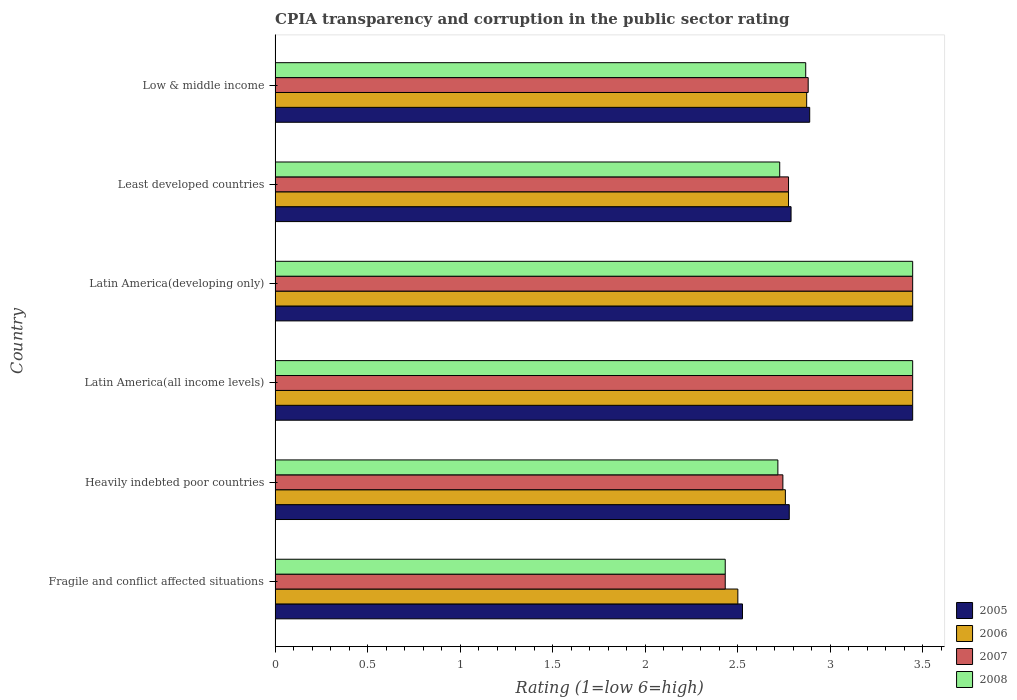How many different coloured bars are there?
Make the answer very short. 4. How many groups of bars are there?
Provide a short and direct response. 6. Are the number of bars per tick equal to the number of legend labels?
Provide a succinct answer. Yes. Are the number of bars on each tick of the Y-axis equal?
Keep it short and to the point. Yes. How many bars are there on the 4th tick from the top?
Keep it short and to the point. 4. How many bars are there on the 1st tick from the bottom?
Your answer should be very brief. 4. What is the label of the 6th group of bars from the top?
Offer a very short reply. Fragile and conflict affected situations. What is the CPIA rating in 2005 in Latin America(all income levels)?
Offer a very short reply. 3.44. Across all countries, what is the maximum CPIA rating in 2005?
Ensure brevity in your answer.  3.44. Across all countries, what is the minimum CPIA rating in 2005?
Make the answer very short. 2.52. In which country was the CPIA rating in 2005 maximum?
Make the answer very short. Latin America(all income levels). In which country was the CPIA rating in 2007 minimum?
Your answer should be very brief. Fragile and conflict affected situations. What is the total CPIA rating in 2006 in the graph?
Provide a short and direct response. 17.79. What is the difference between the CPIA rating in 2008 in Latin America(developing only) and that in Low & middle income?
Your answer should be very brief. 0.58. What is the difference between the CPIA rating in 2008 in Fragile and conflict affected situations and the CPIA rating in 2006 in Latin America(developing only)?
Provide a succinct answer. -1.01. What is the average CPIA rating in 2005 per country?
Ensure brevity in your answer.  2.98. What is the difference between the CPIA rating in 2007 and CPIA rating in 2008 in Least developed countries?
Keep it short and to the point. 0.05. In how many countries, is the CPIA rating in 2006 greater than 3.4 ?
Your answer should be very brief. 2. What is the ratio of the CPIA rating in 2006 in Latin America(all income levels) to that in Least developed countries?
Your response must be concise. 1.24. Is the difference between the CPIA rating in 2007 in Latin America(developing only) and Least developed countries greater than the difference between the CPIA rating in 2008 in Latin America(developing only) and Least developed countries?
Keep it short and to the point. No. What is the difference between the highest and the second highest CPIA rating in 2006?
Ensure brevity in your answer.  0. What is the difference between the highest and the lowest CPIA rating in 2006?
Keep it short and to the point. 0.94. Is it the case that in every country, the sum of the CPIA rating in 2006 and CPIA rating in 2007 is greater than the sum of CPIA rating in 2008 and CPIA rating in 2005?
Offer a terse response. No. What does the 3rd bar from the bottom in Low & middle income represents?
Keep it short and to the point. 2007. How many bars are there?
Offer a very short reply. 24. Are all the bars in the graph horizontal?
Your answer should be compact. Yes. What is the difference between two consecutive major ticks on the X-axis?
Keep it short and to the point. 0.5. Does the graph contain any zero values?
Give a very brief answer. No. Does the graph contain grids?
Give a very brief answer. No. Where does the legend appear in the graph?
Make the answer very short. Bottom right. How many legend labels are there?
Your response must be concise. 4. What is the title of the graph?
Your answer should be compact. CPIA transparency and corruption in the public sector rating. What is the label or title of the X-axis?
Offer a very short reply. Rating (1=low 6=high). What is the label or title of the Y-axis?
Keep it short and to the point. Country. What is the Rating (1=low 6=high) in 2005 in Fragile and conflict affected situations?
Give a very brief answer. 2.52. What is the Rating (1=low 6=high) in 2007 in Fragile and conflict affected situations?
Ensure brevity in your answer.  2.43. What is the Rating (1=low 6=high) of 2008 in Fragile and conflict affected situations?
Give a very brief answer. 2.43. What is the Rating (1=low 6=high) of 2005 in Heavily indebted poor countries?
Your response must be concise. 2.78. What is the Rating (1=low 6=high) of 2006 in Heavily indebted poor countries?
Your answer should be very brief. 2.76. What is the Rating (1=low 6=high) in 2007 in Heavily indebted poor countries?
Offer a very short reply. 2.74. What is the Rating (1=low 6=high) of 2008 in Heavily indebted poor countries?
Make the answer very short. 2.72. What is the Rating (1=low 6=high) in 2005 in Latin America(all income levels)?
Offer a terse response. 3.44. What is the Rating (1=low 6=high) in 2006 in Latin America(all income levels)?
Your answer should be compact. 3.44. What is the Rating (1=low 6=high) of 2007 in Latin America(all income levels)?
Make the answer very short. 3.44. What is the Rating (1=low 6=high) of 2008 in Latin America(all income levels)?
Your answer should be compact. 3.44. What is the Rating (1=low 6=high) in 2005 in Latin America(developing only)?
Offer a terse response. 3.44. What is the Rating (1=low 6=high) in 2006 in Latin America(developing only)?
Provide a succinct answer. 3.44. What is the Rating (1=low 6=high) of 2007 in Latin America(developing only)?
Make the answer very short. 3.44. What is the Rating (1=low 6=high) in 2008 in Latin America(developing only)?
Offer a terse response. 3.44. What is the Rating (1=low 6=high) of 2005 in Least developed countries?
Make the answer very short. 2.79. What is the Rating (1=low 6=high) of 2006 in Least developed countries?
Give a very brief answer. 2.77. What is the Rating (1=low 6=high) in 2007 in Least developed countries?
Offer a terse response. 2.77. What is the Rating (1=low 6=high) in 2008 in Least developed countries?
Provide a succinct answer. 2.73. What is the Rating (1=low 6=high) in 2005 in Low & middle income?
Offer a terse response. 2.89. What is the Rating (1=low 6=high) in 2006 in Low & middle income?
Your answer should be very brief. 2.87. What is the Rating (1=low 6=high) in 2007 in Low & middle income?
Ensure brevity in your answer.  2.88. What is the Rating (1=low 6=high) in 2008 in Low & middle income?
Keep it short and to the point. 2.87. Across all countries, what is the maximum Rating (1=low 6=high) in 2005?
Your answer should be compact. 3.44. Across all countries, what is the maximum Rating (1=low 6=high) of 2006?
Keep it short and to the point. 3.44. Across all countries, what is the maximum Rating (1=low 6=high) in 2007?
Your answer should be compact. 3.44. Across all countries, what is the maximum Rating (1=low 6=high) in 2008?
Give a very brief answer. 3.44. Across all countries, what is the minimum Rating (1=low 6=high) of 2005?
Offer a very short reply. 2.52. Across all countries, what is the minimum Rating (1=low 6=high) in 2007?
Offer a very short reply. 2.43. Across all countries, what is the minimum Rating (1=low 6=high) in 2008?
Provide a short and direct response. 2.43. What is the total Rating (1=low 6=high) in 2005 in the graph?
Ensure brevity in your answer.  17.87. What is the total Rating (1=low 6=high) of 2006 in the graph?
Your response must be concise. 17.79. What is the total Rating (1=low 6=high) of 2007 in the graph?
Ensure brevity in your answer.  17.72. What is the total Rating (1=low 6=high) in 2008 in the graph?
Ensure brevity in your answer.  17.63. What is the difference between the Rating (1=low 6=high) in 2005 in Fragile and conflict affected situations and that in Heavily indebted poor countries?
Offer a very short reply. -0.25. What is the difference between the Rating (1=low 6=high) in 2006 in Fragile and conflict affected situations and that in Heavily indebted poor countries?
Ensure brevity in your answer.  -0.26. What is the difference between the Rating (1=low 6=high) in 2007 in Fragile and conflict affected situations and that in Heavily indebted poor countries?
Provide a short and direct response. -0.31. What is the difference between the Rating (1=low 6=high) in 2008 in Fragile and conflict affected situations and that in Heavily indebted poor countries?
Ensure brevity in your answer.  -0.28. What is the difference between the Rating (1=low 6=high) in 2005 in Fragile and conflict affected situations and that in Latin America(all income levels)?
Keep it short and to the point. -0.92. What is the difference between the Rating (1=low 6=high) of 2006 in Fragile and conflict affected situations and that in Latin America(all income levels)?
Make the answer very short. -0.94. What is the difference between the Rating (1=low 6=high) of 2007 in Fragile and conflict affected situations and that in Latin America(all income levels)?
Make the answer very short. -1.01. What is the difference between the Rating (1=low 6=high) in 2008 in Fragile and conflict affected situations and that in Latin America(all income levels)?
Provide a succinct answer. -1.01. What is the difference between the Rating (1=low 6=high) in 2005 in Fragile and conflict affected situations and that in Latin America(developing only)?
Provide a short and direct response. -0.92. What is the difference between the Rating (1=low 6=high) in 2006 in Fragile and conflict affected situations and that in Latin America(developing only)?
Give a very brief answer. -0.94. What is the difference between the Rating (1=low 6=high) in 2007 in Fragile and conflict affected situations and that in Latin America(developing only)?
Give a very brief answer. -1.01. What is the difference between the Rating (1=low 6=high) of 2008 in Fragile and conflict affected situations and that in Latin America(developing only)?
Offer a terse response. -1.01. What is the difference between the Rating (1=low 6=high) of 2005 in Fragile and conflict affected situations and that in Least developed countries?
Provide a short and direct response. -0.26. What is the difference between the Rating (1=low 6=high) in 2006 in Fragile and conflict affected situations and that in Least developed countries?
Your answer should be very brief. -0.27. What is the difference between the Rating (1=low 6=high) of 2007 in Fragile and conflict affected situations and that in Least developed countries?
Keep it short and to the point. -0.34. What is the difference between the Rating (1=low 6=high) in 2008 in Fragile and conflict affected situations and that in Least developed countries?
Your answer should be compact. -0.29. What is the difference between the Rating (1=low 6=high) of 2005 in Fragile and conflict affected situations and that in Low & middle income?
Make the answer very short. -0.36. What is the difference between the Rating (1=low 6=high) in 2006 in Fragile and conflict affected situations and that in Low & middle income?
Give a very brief answer. -0.37. What is the difference between the Rating (1=low 6=high) of 2007 in Fragile and conflict affected situations and that in Low & middle income?
Keep it short and to the point. -0.45. What is the difference between the Rating (1=low 6=high) in 2008 in Fragile and conflict affected situations and that in Low & middle income?
Offer a terse response. -0.43. What is the difference between the Rating (1=low 6=high) in 2006 in Heavily indebted poor countries and that in Latin America(all income levels)?
Your response must be concise. -0.69. What is the difference between the Rating (1=low 6=high) in 2007 in Heavily indebted poor countries and that in Latin America(all income levels)?
Make the answer very short. -0.7. What is the difference between the Rating (1=low 6=high) of 2008 in Heavily indebted poor countries and that in Latin America(all income levels)?
Make the answer very short. -0.73. What is the difference between the Rating (1=low 6=high) in 2005 in Heavily indebted poor countries and that in Latin America(developing only)?
Offer a very short reply. -0.67. What is the difference between the Rating (1=low 6=high) in 2006 in Heavily indebted poor countries and that in Latin America(developing only)?
Make the answer very short. -0.69. What is the difference between the Rating (1=low 6=high) in 2007 in Heavily indebted poor countries and that in Latin America(developing only)?
Your answer should be very brief. -0.7. What is the difference between the Rating (1=low 6=high) in 2008 in Heavily indebted poor countries and that in Latin America(developing only)?
Your response must be concise. -0.73. What is the difference between the Rating (1=low 6=high) in 2005 in Heavily indebted poor countries and that in Least developed countries?
Provide a short and direct response. -0.01. What is the difference between the Rating (1=low 6=high) in 2006 in Heavily indebted poor countries and that in Least developed countries?
Keep it short and to the point. -0.02. What is the difference between the Rating (1=low 6=high) in 2007 in Heavily indebted poor countries and that in Least developed countries?
Ensure brevity in your answer.  -0.03. What is the difference between the Rating (1=low 6=high) in 2008 in Heavily indebted poor countries and that in Least developed countries?
Give a very brief answer. -0.01. What is the difference between the Rating (1=low 6=high) of 2005 in Heavily indebted poor countries and that in Low & middle income?
Keep it short and to the point. -0.11. What is the difference between the Rating (1=low 6=high) of 2006 in Heavily indebted poor countries and that in Low & middle income?
Your answer should be compact. -0.12. What is the difference between the Rating (1=low 6=high) of 2007 in Heavily indebted poor countries and that in Low & middle income?
Give a very brief answer. -0.14. What is the difference between the Rating (1=low 6=high) in 2008 in Heavily indebted poor countries and that in Low & middle income?
Provide a succinct answer. -0.15. What is the difference between the Rating (1=low 6=high) of 2005 in Latin America(all income levels) and that in Least developed countries?
Provide a succinct answer. 0.66. What is the difference between the Rating (1=low 6=high) in 2006 in Latin America(all income levels) and that in Least developed countries?
Give a very brief answer. 0.67. What is the difference between the Rating (1=low 6=high) in 2007 in Latin America(all income levels) and that in Least developed countries?
Your answer should be compact. 0.67. What is the difference between the Rating (1=low 6=high) in 2008 in Latin America(all income levels) and that in Least developed countries?
Provide a short and direct response. 0.72. What is the difference between the Rating (1=low 6=high) of 2005 in Latin America(all income levels) and that in Low & middle income?
Your response must be concise. 0.56. What is the difference between the Rating (1=low 6=high) in 2006 in Latin America(all income levels) and that in Low & middle income?
Your answer should be very brief. 0.57. What is the difference between the Rating (1=low 6=high) of 2007 in Latin America(all income levels) and that in Low & middle income?
Give a very brief answer. 0.56. What is the difference between the Rating (1=low 6=high) of 2008 in Latin America(all income levels) and that in Low & middle income?
Your answer should be compact. 0.58. What is the difference between the Rating (1=low 6=high) in 2005 in Latin America(developing only) and that in Least developed countries?
Your answer should be compact. 0.66. What is the difference between the Rating (1=low 6=high) in 2006 in Latin America(developing only) and that in Least developed countries?
Provide a short and direct response. 0.67. What is the difference between the Rating (1=low 6=high) of 2007 in Latin America(developing only) and that in Least developed countries?
Make the answer very short. 0.67. What is the difference between the Rating (1=low 6=high) of 2008 in Latin America(developing only) and that in Least developed countries?
Provide a short and direct response. 0.72. What is the difference between the Rating (1=low 6=high) of 2005 in Latin America(developing only) and that in Low & middle income?
Ensure brevity in your answer.  0.56. What is the difference between the Rating (1=low 6=high) of 2006 in Latin America(developing only) and that in Low & middle income?
Keep it short and to the point. 0.57. What is the difference between the Rating (1=low 6=high) of 2007 in Latin America(developing only) and that in Low & middle income?
Your response must be concise. 0.56. What is the difference between the Rating (1=low 6=high) in 2008 in Latin America(developing only) and that in Low & middle income?
Your response must be concise. 0.58. What is the difference between the Rating (1=low 6=high) in 2005 in Least developed countries and that in Low & middle income?
Keep it short and to the point. -0.1. What is the difference between the Rating (1=low 6=high) in 2006 in Least developed countries and that in Low & middle income?
Give a very brief answer. -0.1. What is the difference between the Rating (1=low 6=high) in 2007 in Least developed countries and that in Low & middle income?
Your answer should be very brief. -0.11. What is the difference between the Rating (1=low 6=high) of 2008 in Least developed countries and that in Low & middle income?
Your response must be concise. -0.14. What is the difference between the Rating (1=low 6=high) of 2005 in Fragile and conflict affected situations and the Rating (1=low 6=high) of 2006 in Heavily indebted poor countries?
Your answer should be compact. -0.23. What is the difference between the Rating (1=low 6=high) of 2005 in Fragile and conflict affected situations and the Rating (1=low 6=high) of 2007 in Heavily indebted poor countries?
Give a very brief answer. -0.22. What is the difference between the Rating (1=low 6=high) in 2005 in Fragile and conflict affected situations and the Rating (1=low 6=high) in 2008 in Heavily indebted poor countries?
Give a very brief answer. -0.19. What is the difference between the Rating (1=low 6=high) in 2006 in Fragile and conflict affected situations and the Rating (1=low 6=high) in 2007 in Heavily indebted poor countries?
Your answer should be compact. -0.24. What is the difference between the Rating (1=low 6=high) of 2006 in Fragile and conflict affected situations and the Rating (1=low 6=high) of 2008 in Heavily indebted poor countries?
Keep it short and to the point. -0.22. What is the difference between the Rating (1=low 6=high) in 2007 in Fragile and conflict affected situations and the Rating (1=low 6=high) in 2008 in Heavily indebted poor countries?
Your response must be concise. -0.28. What is the difference between the Rating (1=low 6=high) in 2005 in Fragile and conflict affected situations and the Rating (1=low 6=high) in 2006 in Latin America(all income levels)?
Give a very brief answer. -0.92. What is the difference between the Rating (1=low 6=high) in 2005 in Fragile and conflict affected situations and the Rating (1=low 6=high) in 2007 in Latin America(all income levels)?
Provide a short and direct response. -0.92. What is the difference between the Rating (1=low 6=high) of 2005 in Fragile and conflict affected situations and the Rating (1=low 6=high) of 2008 in Latin America(all income levels)?
Give a very brief answer. -0.92. What is the difference between the Rating (1=low 6=high) in 2006 in Fragile and conflict affected situations and the Rating (1=low 6=high) in 2007 in Latin America(all income levels)?
Offer a very short reply. -0.94. What is the difference between the Rating (1=low 6=high) of 2006 in Fragile and conflict affected situations and the Rating (1=low 6=high) of 2008 in Latin America(all income levels)?
Provide a short and direct response. -0.94. What is the difference between the Rating (1=low 6=high) in 2007 in Fragile and conflict affected situations and the Rating (1=low 6=high) in 2008 in Latin America(all income levels)?
Offer a terse response. -1.01. What is the difference between the Rating (1=low 6=high) of 2005 in Fragile and conflict affected situations and the Rating (1=low 6=high) of 2006 in Latin America(developing only)?
Make the answer very short. -0.92. What is the difference between the Rating (1=low 6=high) in 2005 in Fragile and conflict affected situations and the Rating (1=low 6=high) in 2007 in Latin America(developing only)?
Offer a very short reply. -0.92. What is the difference between the Rating (1=low 6=high) of 2005 in Fragile and conflict affected situations and the Rating (1=low 6=high) of 2008 in Latin America(developing only)?
Your answer should be compact. -0.92. What is the difference between the Rating (1=low 6=high) in 2006 in Fragile and conflict affected situations and the Rating (1=low 6=high) in 2007 in Latin America(developing only)?
Keep it short and to the point. -0.94. What is the difference between the Rating (1=low 6=high) of 2006 in Fragile and conflict affected situations and the Rating (1=low 6=high) of 2008 in Latin America(developing only)?
Give a very brief answer. -0.94. What is the difference between the Rating (1=low 6=high) of 2007 in Fragile and conflict affected situations and the Rating (1=low 6=high) of 2008 in Latin America(developing only)?
Offer a very short reply. -1.01. What is the difference between the Rating (1=low 6=high) of 2005 in Fragile and conflict affected situations and the Rating (1=low 6=high) of 2006 in Least developed countries?
Ensure brevity in your answer.  -0.25. What is the difference between the Rating (1=low 6=high) in 2005 in Fragile and conflict affected situations and the Rating (1=low 6=high) in 2007 in Least developed countries?
Your answer should be very brief. -0.25. What is the difference between the Rating (1=low 6=high) in 2005 in Fragile and conflict affected situations and the Rating (1=low 6=high) in 2008 in Least developed countries?
Give a very brief answer. -0.2. What is the difference between the Rating (1=low 6=high) in 2006 in Fragile and conflict affected situations and the Rating (1=low 6=high) in 2007 in Least developed countries?
Provide a succinct answer. -0.27. What is the difference between the Rating (1=low 6=high) in 2006 in Fragile and conflict affected situations and the Rating (1=low 6=high) in 2008 in Least developed countries?
Ensure brevity in your answer.  -0.23. What is the difference between the Rating (1=low 6=high) in 2007 in Fragile and conflict affected situations and the Rating (1=low 6=high) in 2008 in Least developed countries?
Provide a short and direct response. -0.29. What is the difference between the Rating (1=low 6=high) of 2005 in Fragile and conflict affected situations and the Rating (1=low 6=high) of 2006 in Low & middle income?
Provide a succinct answer. -0.35. What is the difference between the Rating (1=low 6=high) in 2005 in Fragile and conflict affected situations and the Rating (1=low 6=high) in 2007 in Low & middle income?
Your answer should be compact. -0.35. What is the difference between the Rating (1=low 6=high) of 2005 in Fragile and conflict affected situations and the Rating (1=low 6=high) of 2008 in Low & middle income?
Keep it short and to the point. -0.34. What is the difference between the Rating (1=low 6=high) in 2006 in Fragile and conflict affected situations and the Rating (1=low 6=high) in 2007 in Low & middle income?
Offer a very short reply. -0.38. What is the difference between the Rating (1=low 6=high) of 2006 in Fragile and conflict affected situations and the Rating (1=low 6=high) of 2008 in Low & middle income?
Keep it short and to the point. -0.37. What is the difference between the Rating (1=low 6=high) of 2007 in Fragile and conflict affected situations and the Rating (1=low 6=high) of 2008 in Low & middle income?
Offer a very short reply. -0.43. What is the difference between the Rating (1=low 6=high) in 2005 in Heavily indebted poor countries and the Rating (1=low 6=high) in 2006 in Latin America(all income levels)?
Keep it short and to the point. -0.67. What is the difference between the Rating (1=low 6=high) in 2006 in Heavily indebted poor countries and the Rating (1=low 6=high) in 2007 in Latin America(all income levels)?
Your answer should be compact. -0.69. What is the difference between the Rating (1=low 6=high) in 2006 in Heavily indebted poor countries and the Rating (1=low 6=high) in 2008 in Latin America(all income levels)?
Ensure brevity in your answer.  -0.69. What is the difference between the Rating (1=low 6=high) of 2007 in Heavily indebted poor countries and the Rating (1=low 6=high) of 2008 in Latin America(all income levels)?
Keep it short and to the point. -0.7. What is the difference between the Rating (1=low 6=high) in 2005 in Heavily indebted poor countries and the Rating (1=low 6=high) in 2007 in Latin America(developing only)?
Provide a short and direct response. -0.67. What is the difference between the Rating (1=low 6=high) of 2005 in Heavily indebted poor countries and the Rating (1=low 6=high) of 2008 in Latin America(developing only)?
Your response must be concise. -0.67. What is the difference between the Rating (1=low 6=high) of 2006 in Heavily indebted poor countries and the Rating (1=low 6=high) of 2007 in Latin America(developing only)?
Offer a very short reply. -0.69. What is the difference between the Rating (1=low 6=high) of 2006 in Heavily indebted poor countries and the Rating (1=low 6=high) of 2008 in Latin America(developing only)?
Keep it short and to the point. -0.69. What is the difference between the Rating (1=low 6=high) in 2007 in Heavily indebted poor countries and the Rating (1=low 6=high) in 2008 in Latin America(developing only)?
Your answer should be compact. -0.7. What is the difference between the Rating (1=low 6=high) of 2005 in Heavily indebted poor countries and the Rating (1=low 6=high) of 2006 in Least developed countries?
Make the answer very short. 0. What is the difference between the Rating (1=low 6=high) in 2005 in Heavily indebted poor countries and the Rating (1=low 6=high) in 2007 in Least developed countries?
Offer a very short reply. 0. What is the difference between the Rating (1=low 6=high) of 2005 in Heavily indebted poor countries and the Rating (1=low 6=high) of 2008 in Least developed countries?
Your answer should be very brief. 0.05. What is the difference between the Rating (1=low 6=high) in 2006 in Heavily indebted poor countries and the Rating (1=low 6=high) in 2007 in Least developed countries?
Your answer should be very brief. -0.02. What is the difference between the Rating (1=low 6=high) of 2006 in Heavily indebted poor countries and the Rating (1=low 6=high) of 2008 in Least developed countries?
Give a very brief answer. 0.03. What is the difference between the Rating (1=low 6=high) of 2007 in Heavily indebted poor countries and the Rating (1=low 6=high) of 2008 in Least developed countries?
Your answer should be compact. 0.02. What is the difference between the Rating (1=low 6=high) in 2005 in Heavily indebted poor countries and the Rating (1=low 6=high) in 2006 in Low & middle income?
Your answer should be very brief. -0.09. What is the difference between the Rating (1=low 6=high) of 2005 in Heavily indebted poor countries and the Rating (1=low 6=high) of 2007 in Low & middle income?
Give a very brief answer. -0.1. What is the difference between the Rating (1=low 6=high) in 2005 in Heavily indebted poor countries and the Rating (1=low 6=high) in 2008 in Low & middle income?
Offer a terse response. -0.09. What is the difference between the Rating (1=low 6=high) in 2006 in Heavily indebted poor countries and the Rating (1=low 6=high) in 2007 in Low & middle income?
Make the answer very short. -0.12. What is the difference between the Rating (1=low 6=high) in 2006 in Heavily indebted poor countries and the Rating (1=low 6=high) in 2008 in Low & middle income?
Your answer should be compact. -0.11. What is the difference between the Rating (1=low 6=high) in 2007 in Heavily indebted poor countries and the Rating (1=low 6=high) in 2008 in Low & middle income?
Offer a terse response. -0.12. What is the difference between the Rating (1=low 6=high) of 2005 in Latin America(all income levels) and the Rating (1=low 6=high) of 2007 in Latin America(developing only)?
Offer a terse response. 0. What is the difference between the Rating (1=low 6=high) of 2005 in Latin America(all income levels) and the Rating (1=low 6=high) of 2008 in Latin America(developing only)?
Your response must be concise. 0. What is the difference between the Rating (1=low 6=high) of 2006 in Latin America(all income levels) and the Rating (1=low 6=high) of 2008 in Latin America(developing only)?
Give a very brief answer. 0. What is the difference between the Rating (1=low 6=high) of 2007 in Latin America(all income levels) and the Rating (1=low 6=high) of 2008 in Latin America(developing only)?
Provide a short and direct response. 0. What is the difference between the Rating (1=low 6=high) of 2005 in Latin America(all income levels) and the Rating (1=low 6=high) of 2006 in Least developed countries?
Make the answer very short. 0.67. What is the difference between the Rating (1=low 6=high) of 2005 in Latin America(all income levels) and the Rating (1=low 6=high) of 2007 in Least developed countries?
Your answer should be compact. 0.67. What is the difference between the Rating (1=low 6=high) of 2005 in Latin America(all income levels) and the Rating (1=low 6=high) of 2008 in Least developed countries?
Your answer should be very brief. 0.72. What is the difference between the Rating (1=low 6=high) of 2006 in Latin America(all income levels) and the Rating (1=low 6=high) of 2007 in Least developed countries?
Offer a terse response. 0.67. What is the difference between the Rating (1=low 6=high) of 2006 in Latin America(all income levels) and the Rating (1=low 6=high) of 2008 in Least developed countries?
Provide a succinct answer. 0.72. What is the difference between the Rating (1=low 6=high) of 2007 in Latin America(all income levels) and the Rating (1=low 6=high) of 2008 in Least developed countries?
Offer a very short reply. 0.72. What is the difference between the Rating (1=low 6=high) in 2005 in Latin America(all income levels) and the Rating (1=low 6=high) in 2006 in Low & middle income?
Keep it short and to the point. 0.57. What is the difference between the Rating (1=low 6=high) of 2005 in Latin America(all income levels) and the Rating (1=low 6=high) of 2007 in Low & middle income?
Make the answer very short. 0.56. What is the difference between the Rating (1=low 6=high) of 2005 in Latin America(all income levels) and the Rating (1=low 6=high) of 2008 in Low & middle income?
Provide a succinct answer. 0.58. What is the difference between the Rating (1=low 6=high) in 2006 in Latin America(all income levels) and the Rating (1=low 6=high) in 2007 in Low & middle income?
Offer a terse response. 0.56. What is the difference between the Rating (1=low 6=high) of 2006 in Latin America(all income levels) and the Rating (1=low 6=high) of 2008 in Low & middle income?
Keep it short and to the point. 0.58. What is the difference between the Rating (1=low 6=high) of 2007 in Latin America(all income levels) and the Rating (1=low 6=high) of 2008 in Low & middle income?
Your answer should be very brief. 0.58. What is the difference between the Rating (1=low 6=high) in 2005 in Latin America(developing only) and the Rating (1=low 6=high) in 2006 in Least developed countries?
Provide a short and direct response. 0.67. What is the difference between the Rating (1=low 6=high) in 2005 in Latin America(developing only) and the Rating (1=low 6=high) in 2007 in Least developed countries?
Your answer should be compact. 0.67. What is the difference between the Rating (1=low 6=high) of 2005 in Latin America(developing only) and the Rating (1=low 6=high) of 2008 in Least developed countries?
Provide a succinct answer. 0.72. What is the difference between the Rating (1=low 6=high) of 2006 in Latin America(developing only) and the Rating (1=low 6=high) of 2007 in Least developed countries?
Your response must be concise. 0.67. What is the difference between the Rating (1=low 6=high) in 2006 in Latin America(developing only) and the Rating (1=low 6=high) in 2008 in Least developed countries?
Your response must be concise. 0.72. What is the difference between the Rating (1=low 6=high) of 2007 in Latin America(developing only) and the Rating (1=low 6=high) of 2008 in Least developed countries?
Provide a short and direct response. 0.72. What is the difference between the Rating (1=low 6=high) of 2005 in Latin America(developing only) and the Rating (1=low 6=high) of 2006 in Low & middle income?
Provide a succinct answer. 0.57. What is the difference between the Rating (1=low 6=high) in 2005 in Latin America(developing only) and the Rating (1=low 6=high) in 2007 in Low & middle income?
Offer a very short reply. 0.56. What is the difference between the Rating (1=low 6=high) in 2005 in Latin America(developing only) and the Rating (1=low 6=high) in 2008 in Low & middle income?
Provide a succinct answer. 0.58. What is the difference between the Rating (1=low 6=high) of 2006 in Latin America(developing only) and the Rating (1=low 6=high) of 2007 in Low & middle income?
Your response must be concise. 0.56. What is the difference between the Rating (1=low 6=high) of 2006 in Latin America(developing only) and the Rating (1=low 6=high) of 2008 in Low & middle income?
Give a very brief answer. 0.58. What is the difference between the Rating (1=low 6=high) in 2007 in Latin America(developing only) and the Rating (1=low 6=high) in 2008 in Low & middle income?
Your answer should be compact. 0.58. What is the difference between the Rating (1=low 6=high) of 2005 in Least developed countries and the Rating (1=low 6=high) of 2006 in Low & middle income?
Provide a short and direct response. -0.08. What is the difference between the Rating (1=low 6=high) of 2005 in Least developed countries and the Rating (1=low 6=high) of 2007 in Low & middle income?
Give a very brief answer. -0.09. What is the difference between the Rating (1=low 6=high) of 2005 in Least developed countries and the Rating (1=low 6=high) of 2008 in Low & middle income?
Make the answer very short. -0.08. What is the difference between the Rating (1=low 6=high) in 2006 in Least developed countries and the Rating (1=low 6=high) in 2007 in Low & middle income?
Give a very brief answer. -0.11. What is the difference between the Rating (1=low 6=high) of 2006 in Least developed countries and the Rating (1=low 6=high) of 2008 in Low & middle income?
Your response must be concise. -0.09. What is the difference between the Rating (1=low 6=high) in 2007 in Least developed countries and the Rating (1=low 6=high) in 2008 in Low & middle income?
Provide a succinct answer. -0.09. What is the average Rating (1=low 6=high) of 2005 per country?
Make the answer very short. 2.98. What is the average Rating (1=low 6=high) of 2006 per country?
Give a very brief answer. 2.97. What is the average Rating (1=low 6=high) of 2007 per country?
Your answer should be very brief. 2.95. What is the average Rating (1=low 6=high) in 2008 per country?
Your response must be concise. 2.94. What is the difference between the Rating (1=low 6=high) of 2005 and Rating (1=low 6=high) of 2006 in Fragile and conflict affected situations?
Your answer should be very brief. 0.03. What is the difference between the Rating (1=low 6=high) of 2005 and Rating (1=low 6=high) of 2007 in Fragile and conflict affected situations?
Give a very brief answer. 0.09. What is the difference between the Rating (1=low 6=high) in 2005 and Rating (1=low 6=high) in 2008 in Fragile and conflict affected situations?
Ensure brevity in your answer.  0.09. What is the difference between the Rating (1=low 6=high) in 2006 and Rating (1=low 6=high) in 2007 in Fragile and conflict affected situations?
Make the answer very short. 0.07. What is the difference between the Rating (1=low 6=high) of 2006 and Rating (1=low 6=high) of 2008 in Fragile and conflict affected situations?
Offer a very short reply. 0.07. What is the difference between the Rating (1=low 6=high) of 2005 and Rating (1=low 6=high) of 2006 in Heavily indebted poor countries?
Your answer should be very brief. 0.02. What is the difference between the Rating (1=low 6=high) in 2005 and Rating (1=low 6=high) in 2007 in Heavily indebted poor countries?
Keep it short and to the point. 0.03. What is the difference between the Rating (1=low 6=high) in 2005 and Rating (1=low 6=high) in 2008 in Heavily indebted poor countries?
Keep it short and to the point. 0.06. What is the difference between the Rating (1=low 6=high) in 2006 and Rating (1=low 6=high) in 2007 in Heavily indebted poor countries?
Ensure brevity in your answer.  0.01. What is the difference between the Rating (1=low 6=high) in 2006 and Rating (1=low 6=high) in 2008 in Heavily indebted poor countries?
Provide a succinct answer. 0.04. What is the difference between the Rating (1=low 6=high) of 2007 and Rating (1=low 6=high) of 2008 in Heavily indebted poor countries?
Make the answer very short. 0.03. What is the difference between the Rating (1=low 6=high) in 2005 and Rating (1=low 6=high) in 2006 in Latin America(all income levels)?
Offer a terse response. 0. What is the difference between the Rating (1=low 6=high) of 2006 and Rating (1=low 6=high) of 2007 in Latin America(all income levels)?
Provide a succinct answer. 0. What is the difference between the Rating (1=low 6=high) in 2006 and Rating (1=low 6=high) in 2008 in Latin America(all income levels)?
Offer a very short reply. 0. What is the difference between the Rating (1=low 6=high) of 2005 and Rating (1=low 6=high) of 2006 in Latin America(developing only)?
Ensure brevity in your answer.  0. What is the difference between the Rating (1=low 6=high) in 2005 and Rating (1=low 6=high) in 2007 in Latin America(developing only)?
Your response must be concise. 0. What is the difference between the Rating (1=low 6=high) in 2005 and Rating (1=low 6=high) in 2008 in Latin America(developing only)?
Your answer should be very brief. 0. What is the difference between the Rating (1=low 6=high) of 2005 and Rating (1=low 6=high) of 2006 in Least developed countries?
Your answer should be compact. 0.01. What is the difference between the Rating (1=low 6=high) in 2005 and Rating (1=low 6=high) in 2007 in Least developed countries?
Ensure brevity in your answer.  0.01. What is the difference between the Rating (1=low 6=high) in 2005 and Rating (1=low 6=high) in 2008 in Least developed countries?
Give a very brief answer. 0.06. What is the difference between the Rating (1=low 6=high) of 2006 and Rating (1=low 6=high) of 2008 in Least developed countries?
Ensure brevity in your answer.  0.05. What is the difference between the Rating (1=low 6=high) in 2007 and Rating (1=low 6=high) in 2008 in Least developed countries?
Your response must be concise. 0.05. What is the difference between the Rating (1=low 6=high) of 2005 and Rating (1=low 6=high) of 2006 in Low & middle income?
Your response must be concise. 0.02. What is the difference between the Rating (1=low 6=high) of 2005 and Rating (1=low 6=high) of 2007 in Low & middle income?
Offer a very short reply. 0.01. What is the difference between the Rating (1=low 6=high) in 2005 and Rating (1=low 6=high) in 2008 in Low & middle income?
Your response must be concise. 0.02. What is the difference between the Rating (1=low 6=high) in 2006 and Rating (1=low 6=high) in 2007 in Low & middle income?
Offer a terse response. -0.01. What is the difference between the Rating (1=low 6=high) in 2006 and Rating (1=low 6=high) in 2008 in Low & middle income?
Your response must be concise. 0.01. What is the difference between the Rating (1=low 6=high) of 2007 and Rating (1=low 6=high) of 2008 in Low & middle income?
Offer a terse response. 0.01. What is the ratio of the Rating (1=low 6=high) of 2005 in Fragile and conflict affected situations to that in Heavily indebted poor countries?
Provide a succinct answer. 0.91. What is the ratio of the Rating (1=low 6=high) of 2006 in Fragile and conflict affected situations to that in Heavily indebted poor countries?
Your response must be concise. 0.91. What is the ratio of the Rating (1=low 6=high) in 2007 in Fragile and conflict affected situations to that in Heavily indebted poor countries?
Give a very brief answer. 0.89. What is the ratio of the Rating (1=low 6=high) of 2008 in Fragile and conflict affected situations to that in Heavily indebted poor countries?
Provide a succinct answer. 0.9. What is the ratio of the Rating (1=low 6=high) in 2005 in Fragile and conflict affected situations to that in Latin America(all income levels)?
Offer a terse response. 0.73. What is the ratio of the Rating (1=low 6=high) in 2006 in Fragile and conflict affected situations to that in Latin America(all income levels)?
Provide a succinct answer. 0.73. What is the ratio of the Rating (1=low 6=high) in 2007 in Fragile and conflict affected situations to that in Latin America(all income levels)?
Offer a terse response. 0.71. What is the ratio of the Rating (1=low 6=high) in 2008 in Fragile and conflict affected situations to that in Latin America(all income levels)?
Ensure brevity in your answer.  0.71. What is the ratio of the Rating (1=low 6=high) of 2005 in Fragile and conflict affected situations to that in Latin America(developing only)?
Ensure brevity in your answer.  0.73. What is the ratio of the Rating (1=low 6=high) of 2006 in Fragile and conflict affected situations to that in Latin America(developing only)?
Offer a very short reply. 0.73. What is the ratio of the Rating (1=low 6=high) in 2007 in Fragile and conflict affected situations to that in Latin America(developing only)?
Keep it short and to the point. 0.71. What is the ratio of the Rating (1=low 6=high) of 2008 in Fragile and conflict affected situations to that in Latin America(developing only)?
Your answer should be compact. 0.71. What is the ratio of the Rating (1=low 6=high) in 2005 in Fragile and conflict affected situations to that in Least developed countries?
Offer a very short reply. 0.91. What is the ratio of the Rating (1=low 6=high) in 2006 in Fragile and conflict affected situations to that in Least developed countries?
Offer a terse response. 0.9. What is the ratio of the Rating (1=low 6=high) in 2007 in Fragile and conflict affected situations to that in Least developed countries?
Your answer should be very brief. 0.88. What is the ratio of the Rating (1=low 6=high) of 2008 in Fragile and conflict affected situations to that in Least developed countries?
Offer a terse response. 0.89. What is the ratio of the Rating (1=low 6=high) of 2005 in Fragile and conflict affected situations to that in Low & middle income?
Offer a terse response. 0.87. What is the ratio of the Rating (1=low 6=high) in 2006 in Fragile and conflict affected situations to that in Low & middle income?
Offer a terse response. 0.87. What is the ratio of the Rating (1=low 6=high) of 2007 in Fragile and conflict affected situations to that in Low & middle income?
Ensure brevity in your answer.  0.84. What is the ratio of the Rating (1=low 6=high) in 2008 in Fragile and conflict affected situations to that in Low & middle income?
Offer a very short reply. 0.85. What is the ratio of the Rating (1=low 6=high) in 2005 in Heavily indebted poor countries to that in Latin America(all income levels)?
Offer a terse response. 0.81. What is the ratio of the Rating (1=low 6=high) of 2006 in Heavily indebted poor countries to that in Latin America(all income levels)?
Your answer should be compact. 0.8. What is the ratio of the Rating (1=low 6=high) of 2007 in Heavily indebted poor countries to that in Latin America(all income levels)?
Ensure brevity in your answer.  0.8. What is the ratio of the Rating (1=low 6=high) in 2008 in Heavily indebted poor countries to that in Latin America(all income levels)?
Your response must be concise. 0.79. What is the ratio of the Rating (1=low 6=high) in 2005 in Heavily indebted poor countries to that in Latin America(developing only)?
Provide a short and direct response. 0.81. What is the ratio of the Rating (1=low 6=high) of 2006 in Heavily indebted poor countries to that in Latin America(developing only)?
Make the answer very short. 0.8. What is the ratio of the Rating (1=low 6=high) of 2007 in Heavily indebted poor countries to that in Latin America(developing only)?
Offer a terse response. 0.8. What is the ratio of the Rating (1=low 6=high) in 2008 in Heavily indebted poor countries to that in Latin America(developing only)?
Keep it short and to the point. 0.79. What is the ratio of the Rating (1=low 6=high) of 2007 in Heavily indebted poor countries to that in Least developed countries?
Ensure brevity in your answer.  0.99. What is the ratio of the Rating (1=low 6=high) of 2005 in Heavily indebted poor countries to that in Low & middle income?
Your answer should be very brief. 0.96. What is the ratio of the Rating (1=low 6=high) in 2006 in Heavily indebted poor countries to that in Low & middle income?
Make the answer very short. 0.96. What is the ratio of the Rating (1=low 6=high) of 2007 in Heavily indebted poor countries to that in Low & middle income?
Give a very brief answer. 0.95. What is the ratio of the Rating (1=low 6=high) in 2008 in Heavily indebted poor countries to that in Low & middle income?
Give a very brief answer. 0.95. What is the ratio of the Rating (1=low 6=high) of 2006 in Latin America(all income levels) to that in Latin America(developing only)?
Ensure brevity in your answer.  1. What is the ratio of the Rating (1=low 6=high) of 2005 in Latin America(all income levels) to that in Least developed countries?
Make the answer very short. 1.24. What is the ratio of the Rating (1=low 6=high) in 2006 in Latin America(all income levels) to that in Least developed countries?
Make the answer very short. 1.24. What is the ratio of the Rating (1=low 6=high) in 2007 in Latin America(all income levels) to that in Least developed countries?
Offer a terse response. 1.24. What is the ratio of the Rating (1=low 6=high) in 2008 in Latin America(all income levels) to that in Least developed countries?
Offer a very short reply. 1.26. What is the ratio of the Rating (1=low 6=high) in 2005 in Latin America(all income levels) to that in Low & middle income?
Your answer should be compact. 1.19. What is the ratio of the Rating (1=low 6=high) of 2006 in Latin America(all income levels) to that in Low & middle income?
Give a very brief answer. 1.2. What is the ratio of the Rating (1=low 6=high) in 2007 in Latin America(all income levels) to that in Low & middle income?
Keep it short and to the point. 1.2. What is the ratio of the Rating (1=low 6=high) in 2008 in Latin America(all income levels) to that in Low & middle income?
Your response must be concise. 1.2. What is the ratio of the Rating (1=low 6=high) in 2005 in Latin America(developing only) to that in Least developed countries?
Make the answer very short. 1.24. What is the ratio of the Rating (1=low 6=high) of 2006 in Latin America(developing only) to that in Least developed countries?
Offer a terse response. 1.24. What is the ratio of the Rating (1=low 6=high) in 2007 in Latin America(developing only) to that in Least developed countries?
Ensure brevity in your answer.  1.24. What is the ratio of the Rating (1=low 6=high) in 2008 in Latin America(developing only) to that in Least developed countries?
Ensure brevity in your answer.  1.26. What is the ratio of the Rating (1=low 6=high) of 2005 in Latin America(developing only) to that in Low & middle income?
Make the answer very short. 1.19. What is the ratio of the Rating (1=low 6=high) in 2006 in Latin America(developing only) to that in Low & middle income?
Provide a succinct answer. 1.2. What is the ratio of the Rating (1=low 6=high) of 2007 in Latin America(developing only) to that in Low & middle income?
Make the answer very short. 1.2. What is the ratio of the Rating (1=low 6=high) of 2008 in Latin America(developing only) to that in Low & middle income?
Ensure brevity in your answer.  1.2. What is the ratio of the Rating (1=low 6=high) of 2005 in Least developed countries to that in Low & middle income?
Offer a very short reply. 0.97. What is the ratio of the Rating (1=low 6=high) of 2006 in Least developed countries to that in Low & middle income?
Keep it short and to the point. 0.97. What is the ratio of the Rating (1=low 6=high) of 2007 in Least developed countries to that in Low & middle income?
Give a very brief answer. 0.96. What is the ratio of the Rating (1=low 6=high) in 2008 in Least developed countries to that in Low & middle income?
Give a very brief answer. 0.95. What is the difference between the highest and the second highest Rating (1=low 6=high) in 2007?
Your response must be concise. 0. What is the difference between the highest and the lowest Rating (1=low 6=high) in 2005?
Provide a succinct answer. 0.92. What is the difference between the highest and the lowest Rating (1=low 6=high) of 2007?
Offer a terse response. 1.01. What is the difference between the highest and the lowest Rating (1=low 6=high) of 2008?
Keep it short and to the point. 1.01. 